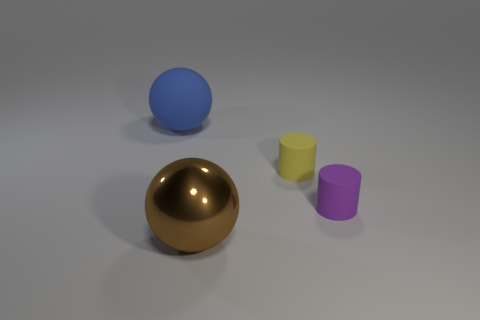Is the material of the large blue object the same as the tiny yellow cylinder that is in front of the blue rubber object?
Give a very brief answer. Yes. There is a brown sphere that is the same size as the blue matte thing; what is it made of?
Make the answer very short. Metal. Are there any other blue things of the same size as the metallic object?
Your answer should be compact. Yes. There is another rubber thing that is the same size as the brown thing; what shape is it?
Your response must be concise. Sphere. There is a object that is behind the brown metallic object and in front of the small yellow rubber object; what is its shape?
Provide a short and direct response. Cylinder. Are there any small things in front of the big object that is behind the small purple object that is on the right side of the large metallic object?
Make the answer very short. Yes. What number of other things are there of the same material as the purple object
Ensure brevity in your answer.  2. How many small rubber cylinders are there?
Keep it short and to the point. 2. What number of objects are either small gray metal objects or balls that are in front of the tiny purple cylinder?
Make the answer very short. 1. There is a sphere that is to the right of the blue matte object; does it have the same size as the small yellow rubber cylinder?
Provide a short and direct response. No. 